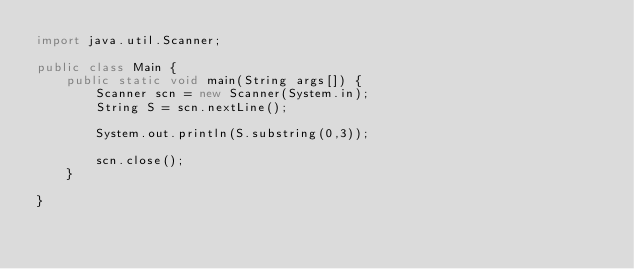<code> <loc_0><loc_0><loc_500><loc_500><_Java_>import java.util.Scanner;

public class Main {
    public static void main(String args[]) {
        Scanner scn = new Scanner(System.in);
        String S = scn.nextLine();

        System.out.println(S.substring(0,3));

        scn.close();
    }

}</code> 